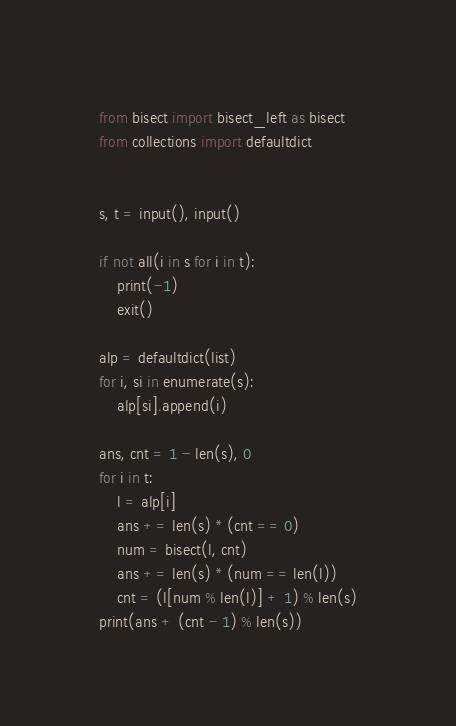Convert code to text. <code><loc_0><loc_0><loc_500><loc_500><_Python_>from bisect import bisect_left as bisect
from collections import defaultdict


s, t = input(), input()

if not all(i in s for i in t):
    print(-1)
    exit()

alp = defaultdict(list)
for i, si in enumerate(s):
    alp[si].append(i)

ans, cnt = 1 - len(s), 0
for i in t:
    l = alp[i]
    ans += len(s) * (cnt == 0)
    num = bisect(l, cnt)
    ans += len(s) * (num == len(l))
    cnt = (l[num % len(l)] + 1) % len(s)
print(ans + (cnt - 1) % len(s))
</code> 